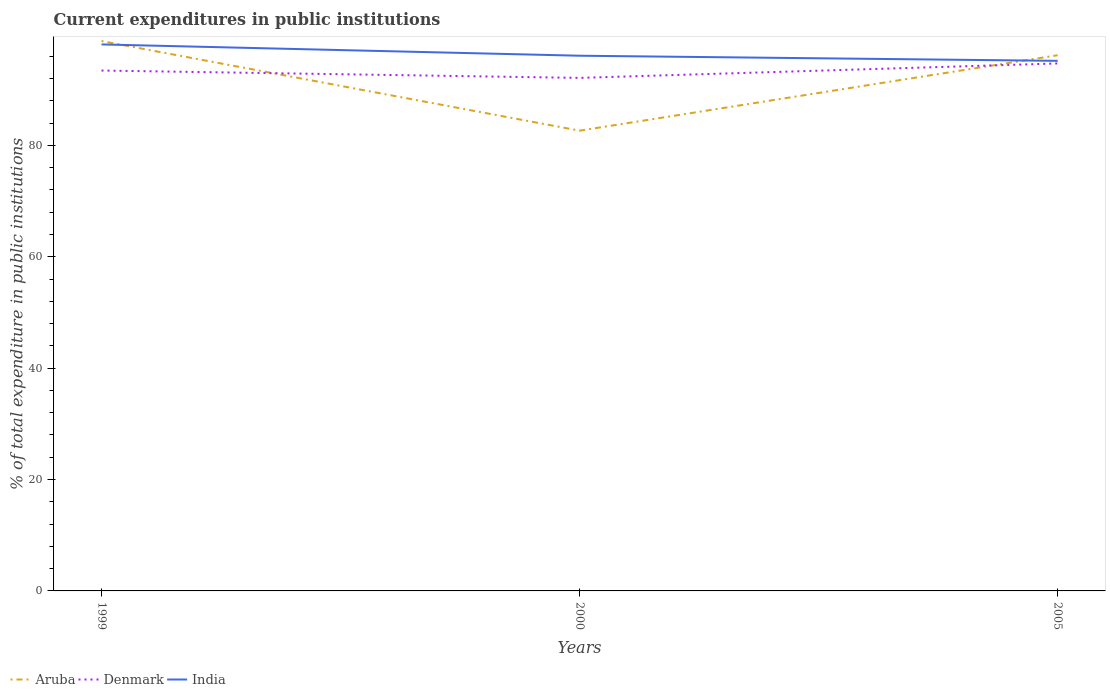Is the number of lines equal to the number of legend labels?
Give a very brief answer. Yes. Across all years, what is the maximum current expenditures in public institutions in Denmark?
Ensure brevity in your answer.  92.12. In which year was the current expenditures in public institutions in India maximum?
Offer a very short reply. 2005. What is the total current expenditures in public institutions in Denmark in the graph?
Make the answer very short. 1.32. What is the difference between the highest and the second highest current expenditures in public institutions in Aruba?
Your answer should be very brief. 16.09. What is the difference between the highest and the lowest current expenditures in public institutions in Aruba?
Make the answer very short. 2. How many lines are there?
Provide a short and direct response. 3. What is the difference between two consecutive major ticks on the Y-axis?
Your answer should be very brief. 20. Where does the legend appear in the graph?
Make the answer very short. Bottom left. How many legend labels are there?
Offer a terse response. 3. What is the title of the graph?
Offer a terse response. Current expenditures in public institutions. What is the label or title of the X-axis?
Ensure brevity in your answer.  Years. What is the label or title of the Y-axis?
Keep it short and to the point. % of total expenditure in public institutions. What is the % of total expenditure in public institutions of Aruba in 1999?
Keep it short and to the point. 98.74. What is the % of total expenditure in public institutions of Denmark in 1999?
Provide a short and direct response. 93.45. What is the % of total expenditure in public institutions of India in 1999?
Your answer should be very brief. 98.13. What is the % of total expenditure in public institutions in Aruba in 2000?
Offer a terse response. 82.65. What is the % of total expenditure in public institutions of Denmark in 2000?
Your response must be concise. 92.12. What is the % of total expenditure in public institutions of India in 2000?
Provide a short and direct response. 96.11. What is the % of total expenditure in public institutions of Aruba in 2005?
Your response must be concise. 96.2. What is the % of total expenditure in public institutions in Denmark in 2005?
Provide a succinct answer. 94.72. What is the % of total expenditure in public institutions in India in 2005?
Make the answer very short. 95.19. Across all years, what is the maximum % of total expenditure in public institutions of Aruba?
Provide a short and direct response. 98.74. Across all years, what is the maximum % of total expenditure in public institutions in Denmark?
Your answer should be very brief. 94.72. Across all years, what is the maximum % of total expenditure in public institutions in India?
Your response must be concise. 98.13. Across all years, what is the minimum % of total expenditure in public institutions in Aruba?
Ensure brevity in your answer.  82.65. Across all years, what is the minimum % of total expenditure in public institutions in Denmark?
Give a very brief answer. 92.12. Across all years, what is the minimum % of total expenditure in public institutions in India?
Offer a very short reply. 95.19. What is the total % of total expenditure in public institutions in Aruba in the graph?
Make the answer very short. 277.58. What is the total % of total expenditure in public institutions in Denmark in the graph?
Make the answer very short. 280.29. What is the total % of total expenditure in public institutions in India in the graph?
Ensure brevity in your answer.  289.43. What is the difference between the % of total expenditure in public institutions of Aruba in 1999 and that in 2000?
Keep it short and to the point. 16.09. What is the difference between the % of total expenditure in public institutions in Denmark in 1999 and that in 2000?
Provide a short and direct response. 1.32. What is the difference between the % of total expenditure in public institutions of India in 1999 and that in 2000?
Offer a terse response. 2.03. What is the difference between the % of total expenditure in public institutions in Aruba in 1999 and that in 2005?
Ensure brevity in your answer.  2.54. What is the difference between the % of total expenditure in public institutions of Denmark in 1999 and that in 2005?
Your answer should be compact. -1.27. What is the difference between the % of total expenditure in public institutions of India in 1999 and that in 2005?
Provide a succinct answer. 2.95. What is the difference between the % of total expenditure in public institutions in Aruba in 2000 and that in 2005?
Provide a short and direct response. -13.55. What is the difference between the % of total expenditure in public institutions of Denmark in 2000 and that in 2005?
Provide a succinct answer. -2.6. What is the difference between the % of total expenditure in public institutions of India in 2000 and that in 2005?
Your answer should be compact. 0.92. What is the difference between the % of total expenditure in public institutions of Aruba in 1999 and the % of total expenditure in public institutions of Denmark in 2000?
Offer a very short reply. 6.62. What is the difference between the % of total expenditure in public institutions in Aruba in 1999 and the % of total expenditure in public institutions in India in 2000?
Ensure brevity in your answer.  2.63. What is the difference between the % of total expenditure in public institutions of Denmark in 1999 and the % of total expenditure in public institutions of India in 2000?
Ensure brevity in your answer.  -2.66. What is the difference between the % of total expenditure in public institutions in Aruba in 1999 and the % of total expenditure in public institutions in Denmark in 2005?
Provide a short and direct response. 4.02. What is the difference between the % of total expenditure in public institutions in Aruba in 1999 and the % of total expenditure in public institutions in India in 2005?
Provide a succinct answer. 3.55. What is the difference between the % of total expenditure in public institutions of Denmark in 1999 and the % of total expenditure in public institutions of India in 2005?
Keep it short and to the point. -1.74. What is the difference between the % of total expenditure in public institutions of Aruba in 2000 and the % of total expenditure in public institutions of Denmark in 2005?
Your answer should be very brief. -12.07. What is the difference between the % of total expenditure in public institutions of Aruba in 2000 and the % of total expenditure in public institutions of India in 2005?
Offer a very short reply. -12.54. What is the difference between the % of total expenditure in public institutions of Denmark in 2000 and the % of total expenditure in public institutions of India in 2005?
Offer a very short reply. -3.06. What is the average % of total expenditure in public institutions in Aruba per year?
Make the answer very short. 92.53. What is the average % of total expenditure in public institutions of Denmark per year?
Provide a succinct answer. 93.43. What is the average % of total expenditure in public institutions of India per year?
Your response must be concise. 96.48. In the year 1999, what is the difference between the % of total expenditure in public institutions in Aruba and % of total expenditure in public institutions in Denmark?
Provide a short and direct response. 5.29. In the year 1999, what is the difference between the % of total expenditure in public institutions of Aruba and % of total expenditure in public institutions of India?
Make the answer very short. 0.6. In the year 1999, what is the difference between the % of total expenditure in public institutions of Denmark and % of total expenditure in public institutions of India?
Offer a very short reply. -4.69. In the year 2000, what is the difference between the % of total expenditure in public institutions in Aruba and % of total expenditure in public institutions in Denmark?
Keep it short and to the point. -9.48. In the year 2000, what is the difference between the % of total expenditure in public institutions in Aruba and % of total expenditure in public institutions in India?
Give a very brief answer. -13.46. In the year 2000, what is the difference between the % of total expenditure in public institutions in Denmark and % of total expenditure in public institutions in India?
Provide a succinct answer. -3.98. In the year 2005, what is the difference between the % of total expenditure in public institutions in Aruba and % of total expenditure in public institutions in Denmark?
Make the answer very short. 1.48. In the year 2005, what is the difference between the % of total expenditure in public institutions of Aruba and % of total expenditure in public institutions of India?
Your answer should be very brief. 1.01. In the year 2005, what is the difference between the % of total expenditure in public institutions in Denmark and % of total expenditure in public institutions in India?
Give a very brief answer. -0.47. What is the ratio of the % of total expenditure in public institutions in Aruba in 1999 to that in 2000?
Give a very brief answer. 1.19. What is the ratio of the % of total expenditure in public institutions of Denmark in 1999 to that in 2000?
Offer a very short reply. 1.01. What is the ratio of the % of total expenditure in public institutions of India in 1999 to that in 2000?
Ensure brevity in your answer.  1.02. What is the ratio of the % of total expenditure in public institutions in Aruba in 1999 to that in 2005?
Give a very brief answer. 1.03. What is the ratio of the % of total expenditure in public institutions in Denmark in 1999 to that in 2005?
Your response must be concise. 0.99. What is the ratio of the % of total expenditure in public institutions in India in 1999 to that in 2005?
Offer a terse response. 1.03. What is the ratio of the % of total expenditure in public institutions in Aruba in 2000 to that in 2005?
Offer a terse response. 0.86. What is the ratio of the % of total expenditure in public institutions in Denmark in 2000 to that in 2005?
Offer a very short reply. 0.97. What is the ratio of the % of total expenditure in public institutions of India in 2000 to that in 2005?
Offer a terse response. 1.01. What is the difference between the highest and the second highest % of total expenditure in public institutions of Aruba?
Your response must be concise. 2.54. What is the difference between the highest and the second highest % of total expenditure in public institutions of Denmark?
Offer a very short reply. 1.27. What is the difference between the highest and the second highest % of total expenditure in public institutions of India?
Offer a terse response. 2.03. What is the difference between the highest and the lowest % of total expenditure in public institutions of Aruba?
Your answer should be compact. 16.09. What is the difference between the highest and the lowest % of total expenditure in public institutions of Denmark?
Keep it short and to the point. 2.6. What is the difference between the highest and the lowest % of total expenditure in public institutions of India?
Keep it short and to the point. 2.95. 